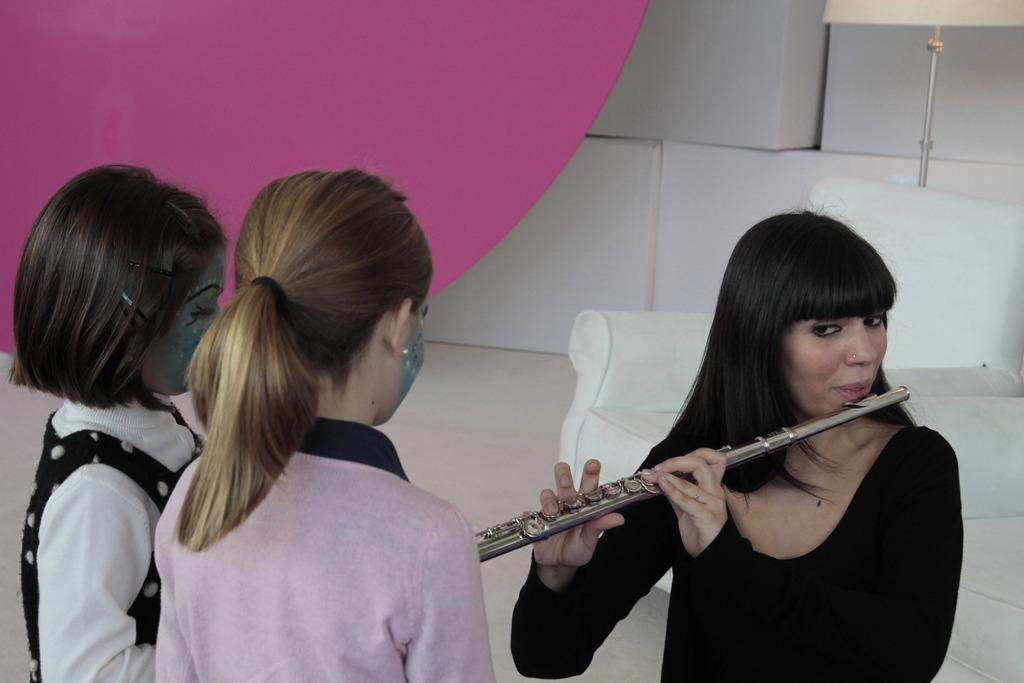How many people are present in the image? There are three people in the image. What is the woman holding in the image? The woman is holding a musical instrument. Can you describe the background of the image? There is a lamp and other objects in the background of the image. What type of things can be seen flying around the woman in the image? There are no things flying around the woman in the image. 